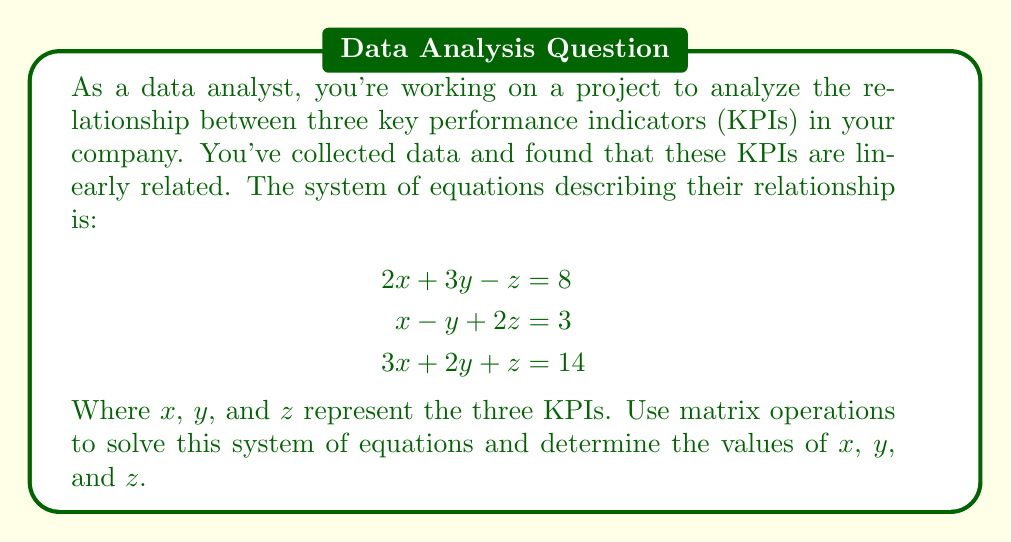Can you solve this math problem? To solve this system using matrix operations, we'll follow these steps:

1) First, we'll express the system in matrix form $AX = B$:

   $$\begin{bmatrix}
   2 & 3 & -1 \\
   1 & -1 & 2 \\
   3 & 2 & 1
   \end{bmatrix}
   \begin{bmatrix}
   x \\
   y \\
   z
   \end{bmatrix} =
   \begin{bmatrix}
   8 \\
   3 \\
   14
   \end{bmatrix}$$

2) To solve for $X$, we need to find $A^{-1}$ and then compute $X = A^{-1}B$.

3) To find $A^{-1}$, we'll calculate:
   
   a) The determinant of $A$:
      $$\det(A) = 2((-1)(1) - 2(2)) + 3((1)(1) - 3(2)) + (-1)((1)(2) - 3(-1)) = -13$$
   
   b) The adjugate matrix of $A$:
      $$\text{adj}(A) = \begin{bmatrix}
      -5 & -5 & 7 \\
      -7 & 5 & 1 \\
      -1 & -2 & 5
      \end{bmatrix}$$

4) Now we can calculate $A^{-1}$:
   $$A^{-1} = \frac{1}{\det(A)} \text{adj}(A) = \frac{1}{-13} \begin{bmatrix}
   -5 & -5 & 7 \\
   -7 & 5 & 1 \\
   -1 & -2 & 5
   \end{bmatrix}$$

5) Finally, we can compute $X = A^{-1}B$:
   $$\begin{aligned}
   X &= \frac{1}{-13} \begin{bmatrix}
   -5 & -5 & 7 \\
   -7 & 5 & 1 \\
   -1 & -2 & 5
   \end{bmatrix}
   \begin{bmatrix}
   8 \\
   3 \\
   14
   \end{bmatrix} \\[10pt]
   &= \frac{1}{-13} \begin{bmatrix}
   -5(8) + (-5)(3) + 7(14) \\
   -7(8) + 5(3) + 1(14) \\
   -1(8) + (-2)(3) + 5(14)
   \end{bmatrix} \\[10pt]
   &= \frac{1}{-13} \begin{bmatrix}
   39 \\
   -26 \\
   52
   \end{bmatrix} \\[10pt]
   &= \begin{bmatrix}
   -3 \\
   2 \\
   -4
   \end{bmatrix}
   \end{aligned}$$
Answer: The solution to the system of equations is $x = -3$, $y = 2$, and $z = -4$. 